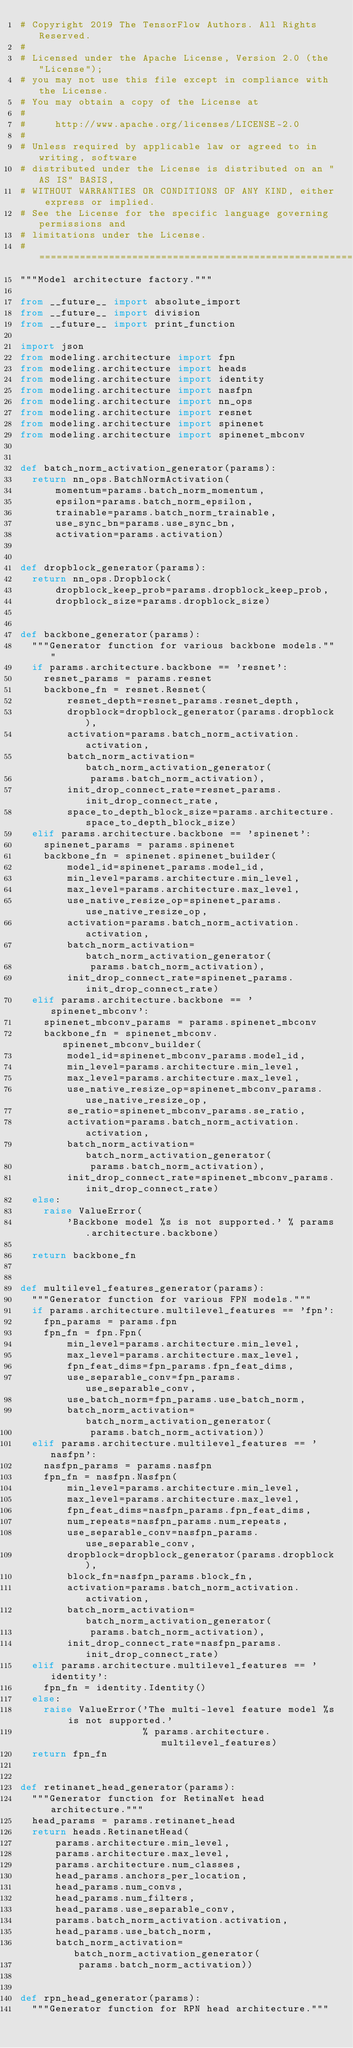Convert code to text. <code><loc_0><loc_0><loc_500><loc_500><_Python_># Copyright 2019 The TensorFlow Authors. All Rights Reserved.
#
# Licensed under the Apache License, Version 2.0 (the "License");
# you may not use this file except in compliance with the License.
# You may obtain a copy of the License at
#
#     http://www.apache.org/licenses/LICENSE-2.0
#
# Unless required by applicable law or agreed to in writing, software
# distributed under the License is distributed on an "AS IS" BASIS,
# WITHOUT WARRANTIES OR CONDITIONS OF ANY KIND, either express or implied.
# See the License for the specific language governing permissions and
# limitations under the License.
# ==============================================================================
"""Model architecture factory."""

from __future__ import absolute_import
from __future__ import division
from __future__ import print_function

import json
from modeling.architecture import fpn
from modeling.architecture import heads
from modeling.architecture import identity
from modeling.architecture import nasfpn
from modeling.architecture import nn_ops
from modeling.architecture import resnet
from modeling.architecture import spinenet
from modeling.architecture import spinenet_mbconv


def batch_norm_activation_generator(params):
  return nn_ops.BatchNormActivation(
      momentum=params.batch_norm_momentum,
      epsilon=params.batch_norm_epsilon,
      trainable=params.batch_norm_trainable,
      use_sync_bn=params.use_sync_bn,
      activation=params.activation)


def dropblock_generator(params):
  return nn_ops.Dropblock(
      dropblock_keep_prob=params.dropblock_keep_prob,
      dropblock_size=params.dropblock_size)


def backbone_generator(params):
  """Generator function for various backbone models."""
  if params.architecture.backbone == 'resnet':
    resnet_params = params.resnet
    backbone_fn = resnet.Resnet(
        resnet_depth=resnet_params.resnet_depth,
        dropblock=dropblock_generator(params.dropblock),
        activation=params.batch_norm_activation.activation,
        batch_norm_activation=batch_norm_activation_generator(
            params.batch_norm_activation),
        init_drop_connect_rate=resnet_params.init_drop_connect_rate,
        space_to_depth_block_size=params.architecture.space_to_depth_block_size)
  elif params.architecture.backbone == 'spinenet':
    spinenet_params = params.spinenet
    backbone_fn = spinenet.spinenet_builder(
        model_id=spinenet_params.model_id,
        min_level=params.architecture.min_level,
        max_level=params.architecture.max_level,
        use_native_resize_op=spinenet_params.use_native_resize_op,
        activation=params.batch_norm_activation.activation,
        batch_norm_activation=batch_norm_activation_generator(
            params.batch_norm_activation),
        init_drop_connect_rate=spinenet_params.init_drop_connect_rate)
  elif params.architecture.backbone == 'spinenet_mbconv':
    spinenet_mbconv_params = params.spinenet_mbconv
    backbone_fn = spinenet_mbconv.spinenet_mbconv_builder(
        model_id=spinenet_mbconv_params.model_id,
        min_level=params.architecture.min_level,
        max_level=params.architecture.max_level,
        use_native_resize_op=spinenet_mbconv_params.use_native_resize_op,
        se_ratio=spinenet_mbconv_params.se_ratio,
        activation=params.batch_norm_activation.activation,
        batch_norm_activation=batch_norm_activation_generator(
            params.batch_norm_activation),
        init_drop_connect_rate=spinenet_mbconv_params.init_drop_connect_rate)
  else:
    raise ValueError(
        'Backbone model %s is not supported.' % params.architecture.backbone)

  return backbone_fn


def multilevel_features_generator(params):
  """Generator function for various FPN models."""
  if params.architecture.multilevel_features == 'fpn':
    fpn_params = params.fpn
    fpn_fn = fpn.Fpn(
        min_level=params.architecture.min_level,
        max_level=params.architecture.max_level,
        fpn_feat_dims=fpn_params.fpn_feat_dims,
        use_separable_conv=fpn_params.use_separable_conv,
        use_batch_norm=fpn_params.use_batch_norm,
        batch_norm_activation=batch_norm_activation_generator(
            params.batch_norm_activation))
  elif params.architecture.multilevel_features == 'nasfpn':
    nasfpn_params = params.nasfpn
    fpn_fn = nasfpn.Nasfpn(
        min_level=params.architecture.min_level,
        max_level=params.architecture.max_level,
        fpn_feat_dims=nasfpn_params.fpn_feat_dims,
        num_repeats=nasfpn_params.num_repeats,
        use_separable_conv=nasfpn_params.use_separable_conv,
        dropblock=dropblock_generator(params.dropblock),
        block_fn=nasfpn_params.block_fn,
        activation=params.batch_norm_activation.activation,
        batch_norm_activation=batch_norm_activation_generator(
            params.batch_norm_activation),
        init_drop_connect_rate=nasfpn_params.init_drop_connect_rate)
  elif params.architecture.multilevel_features == 'identity':
    fpn_fn = identity.Identity()
  else:
    raise ValueError('The multi-level feature model %s is not supported.'
                     % params.architecture.multilevel_features)
  return fpn_fn


def retinanet_head_generator(params):
  """Generator function for RetinaNet head architecture."""
  head_params = params.retinanet_head
  return heads.RetinanetHead(
      params.architecture.min_level,
      params.architecture.max_level,
      params.architecture.num_classes,
      head_params.anchors_per_location,
      head_params.num_convs,
      head_params.num_filters,
      head_params.use_separable_conv,
      params.batch_norm_activation.activation,
      head_params.use_batch_norm,
      batch_norm_activation=batch_norm_activation_generator(
          params.batch_norm_activation))


def rpn_head_generator(params):
  """Generator function for RPN head architecture."""</code> 